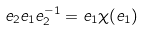Convert formula to latex. <formula><loc_0><loc_0><loc_500><loc_500>e _ { 2 } e _ { 1 } e _ { 2 } ^ { - 1 } = e _ { 1 } \chi ( e _ { 1 } )</formula> 